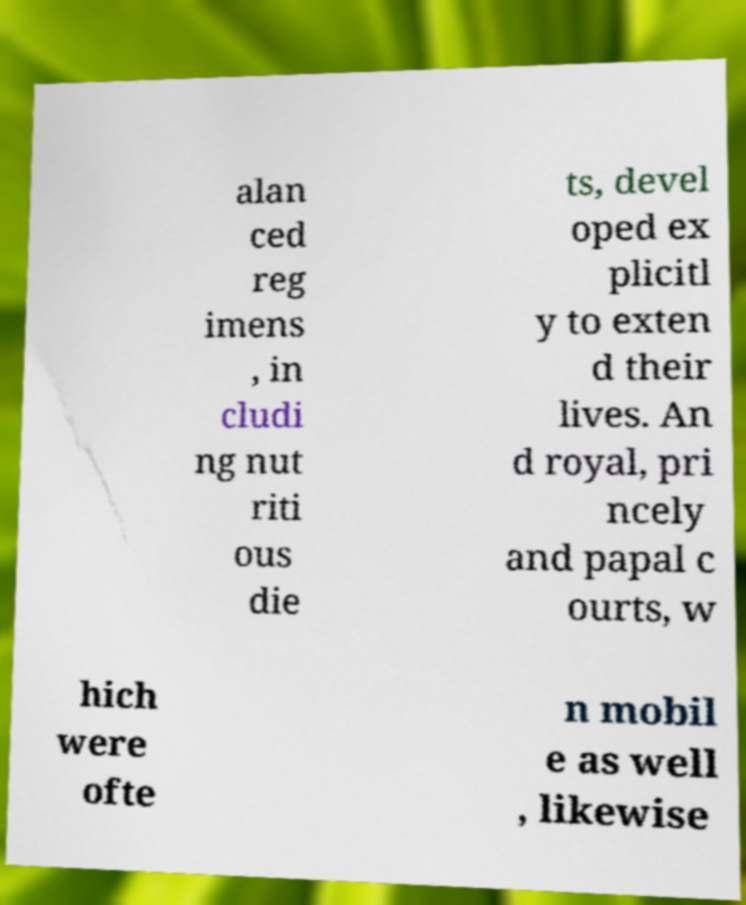Please read and relay the text visible in this image. What does it say? alan ced reg imens , in cludi ng nut riti ous die ts, devel oped ex plicitl y to exten d their lives. An d royal, pri ncely and papal c ourts, w hich were ofte n mobil e as well , likewise 